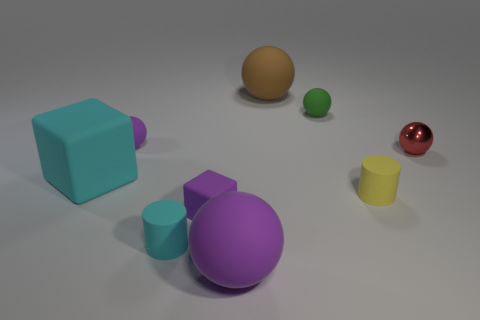Subtract all blue cubes. How many purple balls are left? 2 Add 1 tiny balls. How many objects exist? 10 Subtract all small green balls. How many balls are left? 4 Subtract all brown spheres. How many spheres are left? 4 Subtract 3 spheres. How many spheres are left? 2 Subtract all blocks. How many objects are left? 7 Subtract all blue spheres. Subtract all yellow cylinders. How many spheres are left? 5 Add 3 green matte balls. How many green matte balls are left? 4 Add 3 small blue metallic cylinders. How many small blue metallic cylinders exist? 3 Subtract 0 gray balls. How many objects are left? 9 